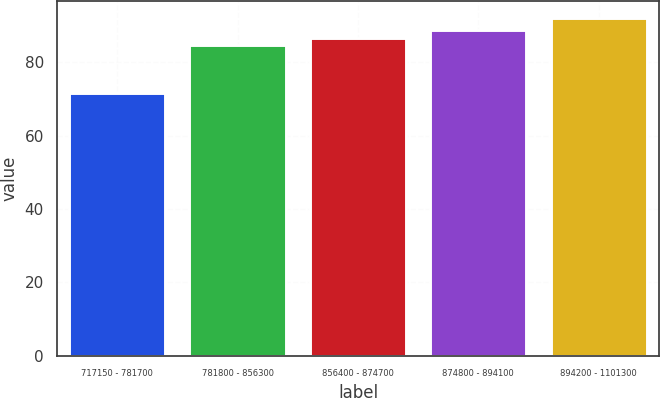<chart> <loc_0><loc_0><loc_500><loc_500><bar_chart><fcel>717150 - 781700<fcel>781800 - 856300<fcel>856400 - 874700<fcel>874800 - 894100<fcel>894200 - 1101300<nl><fcel>71.72<fcel>84.63<fcel>86.66<fcel>88.69<fcel>91.99<nl></chart> 